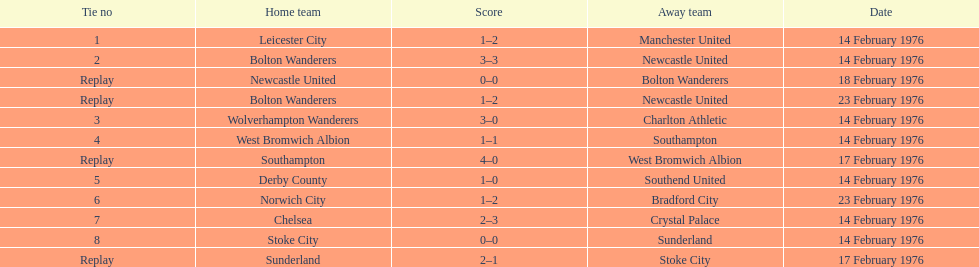Could you parse the entire table? {'header': ['Tie no', 'Home team', 'Score', 'Away team', 'Date'], 'rows': [['1', 'Leicester City', '1–2', 'Manchester United', '14 February 1976'], ['2', 'Bolton Wanderers', '3–3', 'Newcastle United', '14 February 1976'], ['Replay', 'Newcastle United', '0–0', 'Bolton Wanderers', '18 February 1976'], ['Replay', 'Bolton Wanderers', '1–2', 'Newcastle United', '23 February 1976'], ['3', 'Wolverhampton Wanderers', '3–0', 'Charlton Athletic', '14 February 1976'], ['4', 'West Bromwich Albion', '1–1', 'Southampton', '14 February 1976'], ['Replay', 'Southampton', '4–0', 'West Bromwich Albion', '17 February 1976'], ['5', 'Derby County', '1–0', 'Southend United', '14 February 1976'], ['6', 'Norwich City', '1–2', 'Bradford City', '23 February 1976'], ['7', 'Chelsea', '2–3', 'Crystal Palace', '14 February 1976'], ['8', 'Stoke City', '0–0', 'Sunderland', '14 February 1976'], ['Replay', 'Sunderland', '2–1', 'Stoke City', '17 February 1976']]} How many games played by sunderland are listed here? 2. 